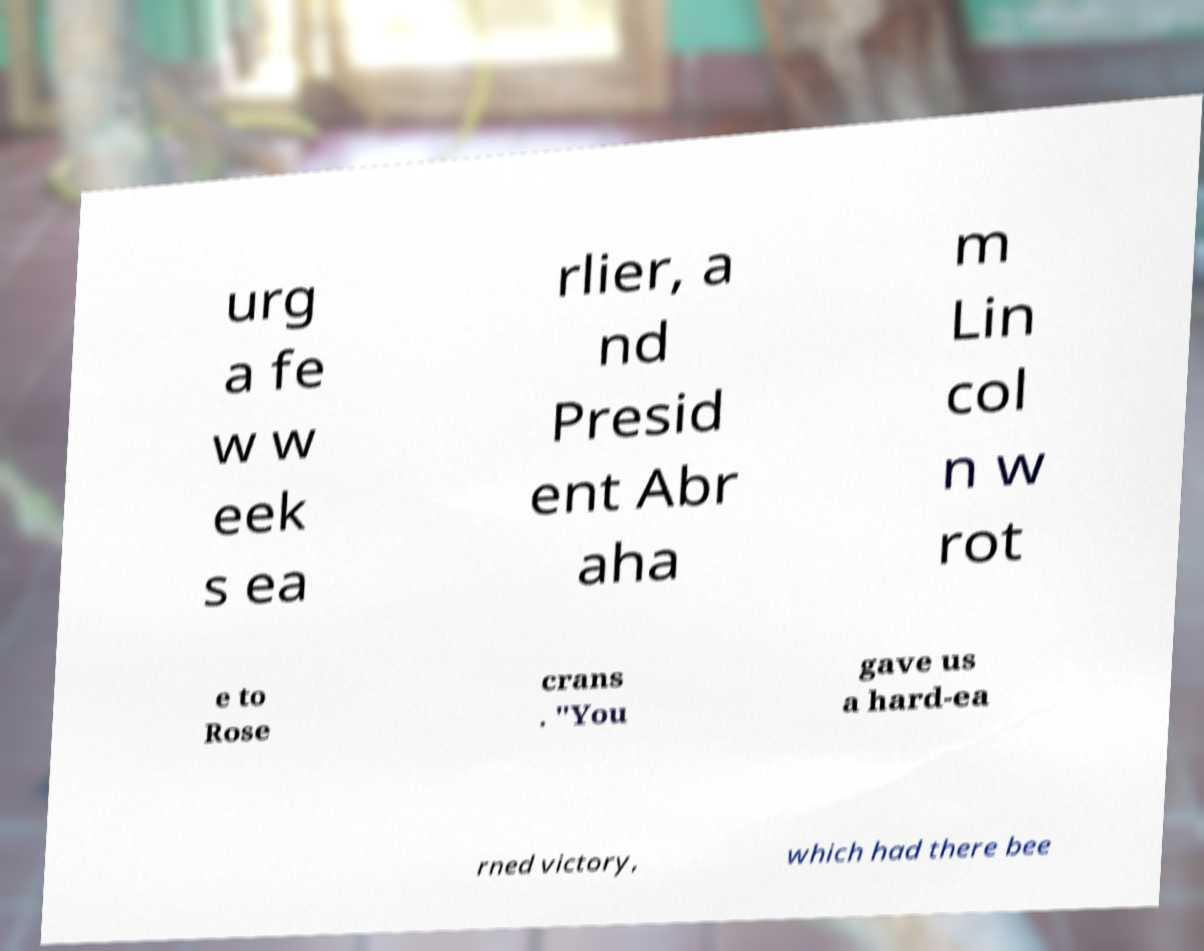I need the written content from this picture converted into text. Can you do that? urg a fe w w eek s ea rlier, a nd Presid ent Abr aha m Lin col n w rot e to Rose crans . "You gave us a hard-ea rned victory, which had there bee 